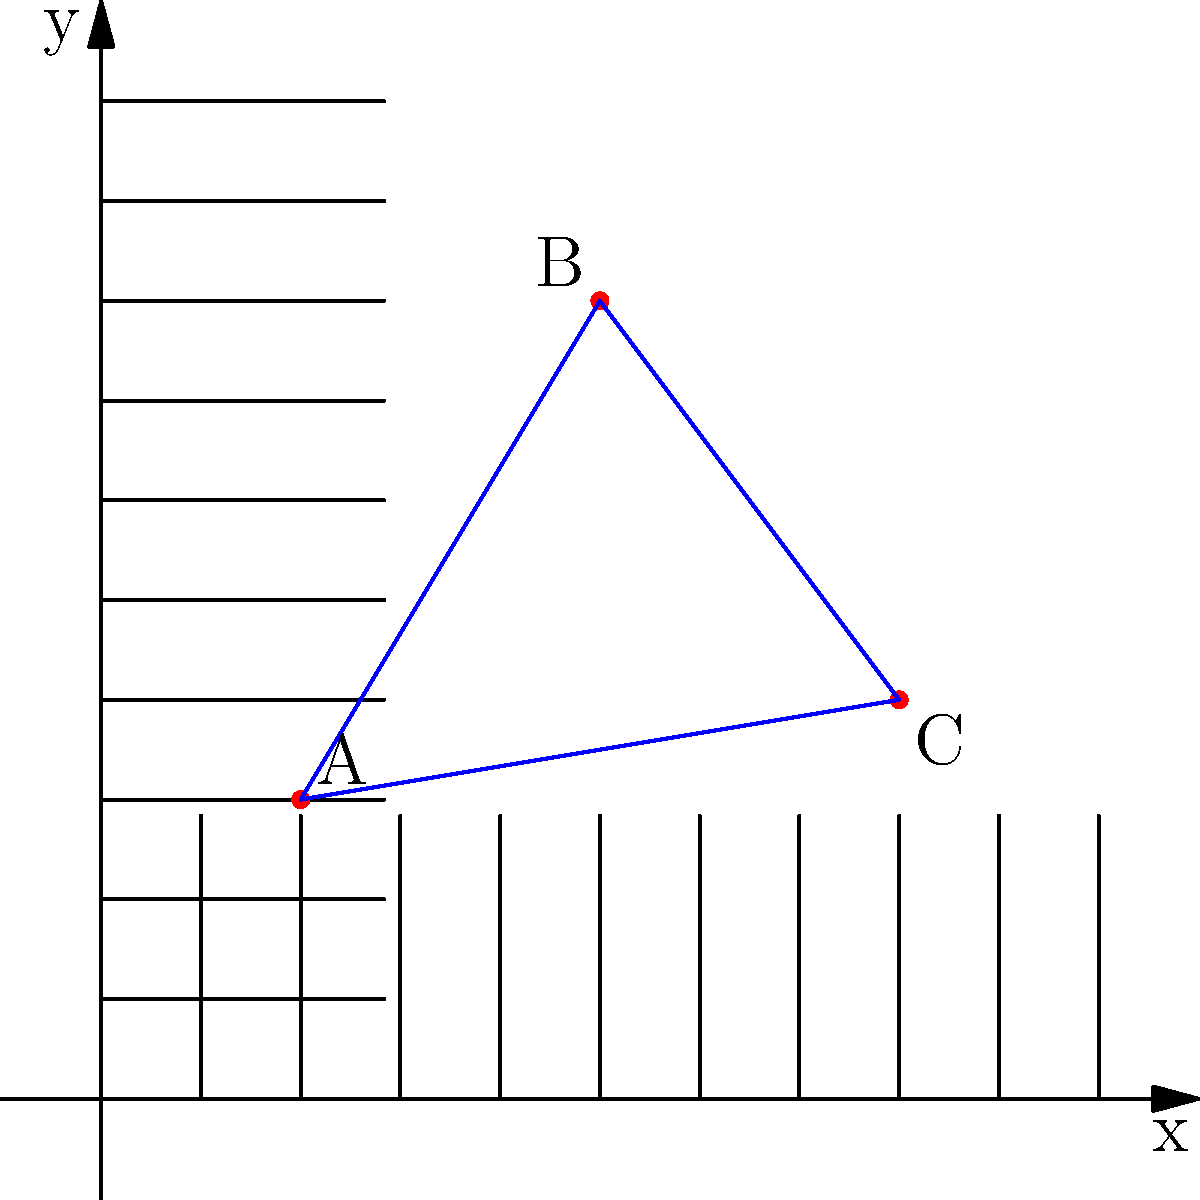In designing a treasure map for a children's adventure story, you've placed three key locations: the starting point (A), a hidden clue (B), and the treasure (C). The coordinates for these points are A(2,3), B(5,8), and C(8,4). What is the total distance the characters must travel if they visit these locations in order (A to B to C), rounded to the nearest whole number? To solve this problem, we'll use the distance formula between two points and add the distances:

1. Distance formula: $d = \sqrt{(x_2-x_1)^2 + (y_2-y_1)^2}$

2. Calculate distance from A to B:
   $d_{AB} = \sqrt{(5-2)^2 + (8-3)^2} = \sqrt{3^2 + 5^2} = \sqrt{9 + 25} = \sqrt{34} \approx 5.83$

3. Calculate distance from B to C:
   $d_{BC} = \sqrt{(8-5)^2 + (4-8)^2} = \sqrt{3^2 + (-4)^2} = \sqrt{9 + 16} = \sqrt{25} = 5$

4. Total distance:
   $d_{total} = d_{AB} + d_{BC} \approx 5.83 + 5 = 10.83$

5. Rounding to the nearest whole number:
   $10.83 \approx 11$

Therefore, the total distance traveled is approximately 11 units.
Answer: 11 units 